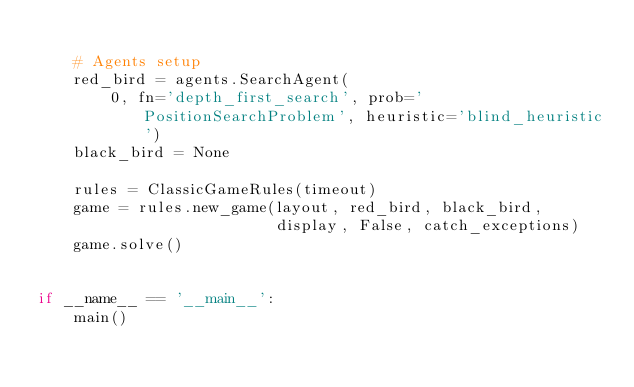Convert code to text. <code><loc_0><loc_0><loc_500><loc_500><_Python_>
    # Agents setup
    red_bird = agents.SearchAgent(
        0, fn='depth_first_search', prob='PositionSearchProblem', heuristic='blind_heuristic')
    black_bird = None

    rules = ClassicGameRules(timeout)
    game = rules.new_game(layout, red_bird, black_bird,
                          display, False, catch_exceptions)
    game.solve()


if __name__ == '__main__':
    main()
</code> 